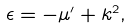Convert formula to latex. <formula><loc_0><loc_0><loc_500><loc_500>\epsilon = - \mu ^ { \prime } + k ^ { 2 } ,</formula> 